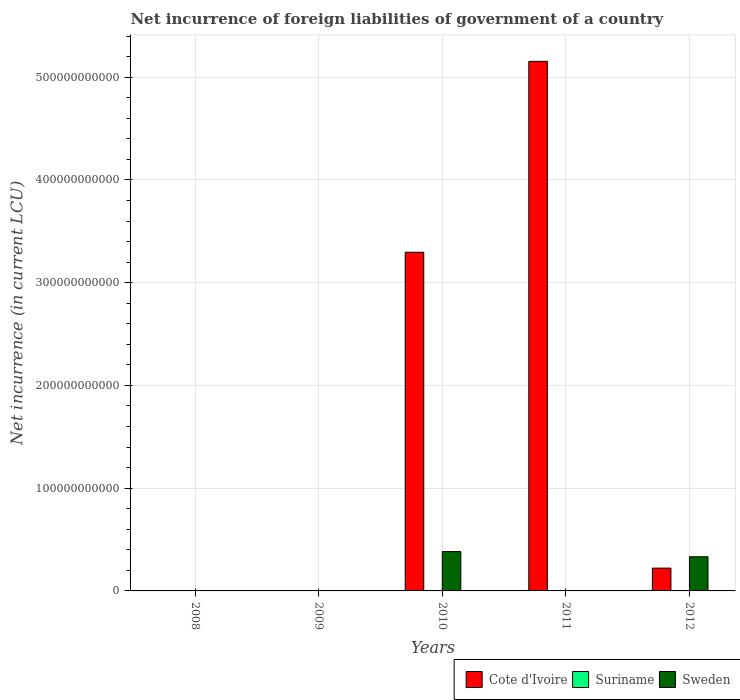How many bars are there on the 1st tick from the left?
Offer a terse response. 1. What is the label of the 1st group of bars from the left?
Your answer should be compact. 2008. What is the net incurrence of foreign liabilities in Suriname in 2011?
Provide a succinct answer. 4.14e+08. Across all years, what is the maximum net incurrence of foreign liabilities in Suriname?
Your answer should be very brief. 4.14e+08. What is the total net incurrence of foreign liabilities in Cote d'Ivoire in the graph?
Your response must be concise. 8.67e+11. What is the difference between the net incurrence of foreign liabilities in Suriname in 2010 and that in 2012?
Your response must be concise. -1.63e+08. What is the difference between the net incurrence of foreign liabilities in Suriname in 2009 and the net incurrence of foreign liabilities in Sweden in 2012?
Make the answer very short. -3.32e+1. What is the average net incurrence of foreign liabilities in Suriname per year?
Offer a very short reply. 1.96e+08. In the year 2010, what is the difference between the net incurrence of foreign liabilities in Suriname and net incurrence of foreign liabilities in Cote d'Ivoire?
Keep it short and to the point. -3.29e+11. What is the ratio of the net incurrence of foreign liabilities in Cote d'Ivoire in 2010 to that in 2012?
Ensure brevity in your answer.  14.85. What is the difference between the highest and the second highest net incurrence of foreign liabilities in Cote d'Ivoire?
Offer a very short reply. 1.86e+11. What is the difference between the highest and the lowest net incurrence of foreign liabilities in Suriname?
Provide a short and direct response. 4.14e+08. Are all the bars in the graph horizontal?
Make the answer very short. No. How many years are there in the graph?
Keep it short and to the point. 5. What is the difference between two consecutive major ticks on the Y-axis?
Your answer should be very brief. 1.00e+11. Are the values on the major ticks of Y-axis written in scientific E-notation?
Provide a succinct answer. No. What is the title of the graph?
Your answer should be very brief. Net incurrence of foreign liabilities of government of a country. What is the label or title of the Y-axis?
Provide a short and direct response. Net incurrence (in current LCU). What is the Net incurrence (in current LCU) of Cote d'Ivoire in 2008?
Your answer should be very brief. 0. What is the Net incurrence (in current LCU) of Suriname in 2008?
Your response must be concise. 3.38e+07. What is the Net incurrence (in current LCU) in Cote d'Ivoire in 2009?
Your answer should be very brief. 0. What is the Net incurrence (in current LCU) in Suriname in 2009?
Keep it short and to the point. 0. What is the Net incurrence (in current LCU) in Cote d'Ivoire in 2010?
Your response must be concise. 3.30e+11. What is the Net incurrence (in current LCU) of Suriname in 2010?
Your answer should be very brief. 1.84e+08. What is the Net incurrence (in current LCU) of Sweden in 2010?
Your response must be concise. 3.83e+1. What is the Net incurrence (in current LCU) in Cote d'Ivoire in 2011?
Give a very brief answer. 5.15e+11. What is the Net incurrence (in current LCU) of Suriname in 2011?
Offer a terse response. 4.14e+08. What is the Net incurrence (in current LCU) in Sweden in 2011?
Provide a short and direct response. 0. What is the Net incurrence (in current LCU) in Cote d'Ivoire in 2012?
Offer a very short reply. 2.22e+1. What is the Net incurrence (in current LCU) of Suriname in 2012?
Offer a very short reply. 3.48e+08. What is the Net incurrence (in current LCU) in Sweden in 2012?
Ensure brevity in your answer.  3.32e+1. Across all years, what is the maximum Net incurrence (in current LCU) in Cote d'Ivoire?
Your answer should be compact. 5.15e+11. Across all years, what is the maximum Net incurrence (in current LCU) in Suriname?
Keep it short and to the point. 4.14e+08. Across all years, what is the maximum Net incurrence (in current LCU) in Sweden?
Your answer should be very brief. 3.83e+1. Across all years, what is the minimum Net incurrence (in current LCU) in Cote d'Ivoire?
Make the answer very short. 0. What is the total Net incurrence (in current LCU) of Cote d'Ivoire in the graph?
Ensure brevity in your answer.  8.67e+11. What is the total Net incurrence (in current LCU) of Suriname in the graph?
Keep it short and to the point. 9.80e+08. What is the total Net incurrence (in current LCU) of Sweden in the graph?
Keep it short and to the point. 7.15e+1. What is the difference between the Net incurrence (in current LCU) in Suriname in 2008 and that in 2010?
Offer a terse response. -1.51e+08. What is the difference between the Net incurrence (in current LCU) in Suriname in 2008 and that in 2011?
Ensure brevity in your answer.  -3.80e+08. What is the difference between the Net incurrence (in current LCU) in Suriname in 2008 and that in 2012?
Make the answer very short. -3.14e+08. What is the difference between the Net incurrence (in current LCU) of Cote d'Ivoire in 2010 and that in 2011?
Offer a terse response. -1.86e+11. What is the difference between the Net incurrence (in current LCU) in Suriname in 2010 and that in 2011?
Offer a very short reply. -2.29e+08. What is the difference between the Net incurrence (in current LCU) in Cote d'Ivoire in 2010 and that in 2012?
Make the answer very short. 3.07e+11. What is the difference between the Net incurrence (in current LCU) in Suriname in 2010 and that in 2012?
Your answer should be compact. -1.63e+08. What is the difference between the Net incurrence (in current LCU) of Sweden in 2010 and that in 2012?
Your response must be concise. 5.04e+09. What is the difference between the Net incurrence (in current LCU) of Cote d'Ivoire in 2011 and that in 2012?
Give a very brief answer. 4.93e+11. What is the difference between the Net incurrence (in current LCU) in Suriname in 2011 and that in 2012?
Provide a succinct answer. 6.60e+07. What is the difference between the Net incurrence (in current LCU) of Suriname in 2008 and the Net incurrence (in current LCU) of Sweden in 2010?
Your answer should be compact. -3.83e+1. What is the difference between the Net incurrence (in current LCU) in Suriname in 2008 and the Net incurrence (in current LCU) in Sweden in 2012?
Your answer should be very brief. -3.32e+1. What is the difference between the Net incurrence (in current LCU) in Cote d'Ivoire in 2010 and the Net incurrence (in current LCU) in Suriname in 2011?
Your answer should be very brief. 3.29e+11. What is the difference between the Net incurrence (in current LCU) in Cote d'Ivoire in 2010 and the Net incurrence (in current LCU) in Suriname in 2012?
Your answer should be compact. 3.29e+11. What is the difference between the Net incurrence (in current LCU) in Cote d'Ivoire in 2010 and the Net incurrence (in current LCU) in Sweden in 2012?
Make the answer very short. 2.96e+11. What is the difference between the Net incurrence (in current LCU) of Suriname in 2010 and the Net incurrence (in current LCU) of Sweden in 2012?
Provide a succinct answer. -3.31e+1. What is the difference between the Net incurrence (in current LCU) of Cote d'Ivoire in 2011 and the Net incurrence (in current LCU) of Suriname in 2012?
Provide a succinct answer. 5.15e+11. What is the difference between the Net incurrence (in current LCU) in Cote d'Ivoire in 2011 and the Net incurrence (in current LCU) in Sweden in 2012?
Your answer should be compact. 4.82e+11. What is the difference between the Net incurrence (in current LCU) in Suriname in 2011 and the Net incurrence (in current LCU) in Sweden in 2012?
Your answer should be compact. -3.28e+1. What is the average Net incurrence (in current LCU) in Cote d'Ivoire per year?
Give a very brief answer. 1.73e+11. What is the average Net incurrence (in current LCU) in Suriname per year?
Provide a short and direct response. 1.96e+08. What is the average Net incurrence (in current LCU) of Sweden per year?
Your answer should be very brief. 1.43e+1. In the year 2010, what is the difference between the Net incurrence (in current LCU) of Cote d'Ivoire and Net incurrence (in current LCU) of Suriname?
Offer a terse response. 3.29e+11. In the year 2010, what is the difference between the Net incurrence (in current LCU) of Cote d'Ivoire and Net incurrence (in current LCU) of Sweden?
Offer a very short reply. 2.91e+11. In the year 2010, what is the difference between the Net incurrence (in current LCU) of Suriname and Net incurrence (in current LCU) of Sweden?
Your response must be concise. -3.81e+1. In the year 2011, what is the difference between the Net incurrence (in current LCU) of Cote d'Ivoire and Net incurrence (in current LCU) of Suriname?
Ensure brevity in your answer.  5.15e+11. In the year 2012, what is the difference between the Net incurrence (in current LCU) in Cote d'Ivoire and Net incurrence (in current LCU) in Suriname?
Your response must be concise. 2.19e+1. In the year 2012, what is the difference between the Net incurrence (in current LCU) of Cote d'Ivoire and Net incurrence (in current LCU) of Sweden?
Your answer should be compact. -1.11e+1. In the year 2012, what is the difference between the Net incurrence (in current LCU) in Suriname and Net incurrence (in current LCU) in Sweden?
Provide a succinct answer. -3.29e+1. What is the ratio of the Net incurrence (in current LCU) in Suriname in 2008 to that in 2010?
Your answer should be compact. 0.18. What is the ratio of the Net incurrence (in current LCU) in Suriname in 2008 to that in 2011?
Your answer should be compact. 0.08. What is the ratio of the Net incurrence (in current LCU) in Suriname in 2008 to that in 2012?
Your answer should be compact. 0.1. What is the ratio of the Net incurrence (in current LCU) in Cote d'Ivoire in 2010 to that in 2011?
Your response must be concise. 0.64. What is the ratio of the Net incurrence (in current LCU) in Suriname in 2010 to that in 2011?
Offer a very short reply. 0.45. What is the ratio of the Net incurrence (in current LCU) in Cote d'Ivoire in 2010 to that in 2012?
Offer a very short reply. 14.85. What is the ratio of the Net incurrence (in current LCU) in Suriname in 2010 to that in 2012?
Your answer should be compact. 0.53. What is the ratio of the Net incurrence (in current LCU) of Sweden in 2010 to that in 2012?
Your answer should be compact. 1.15. What is the ratio of the Net incurrence (in current LCU) in Cote d'Ivoire in 2011 to that in 2012?
Give a very brief answer. 23.22. What is the ratio of the Net incurrence (in current LCU) of Suriname in 2011 to that in 2012?
Your answer should be very brief. 1.19. What is the difference between the highest and the second highest Net incurrence (in current LCU) in Cote d'Ivoire?
Make the answer very short. 1.86e+11. What is the difference between the highest and the second highest Net incurrence (in current LCU) of Suriname?
Keep it short and to the point. 6.60e+07. What is the difference between the highest and the lowest Net incurrence (in current LCU) in Cote d'Ivoire?
Offer a very short reply. 5.15e+11. What is the difference between the highest and the lowest Net incurrence (in current LCU) in Suriname?
Make the answer very short. 4.14e+08. What is the difference between the highest and the lowest Net incurrence (in current LCU) in Sweden?
Make the answer very short. 3.83e+1. 